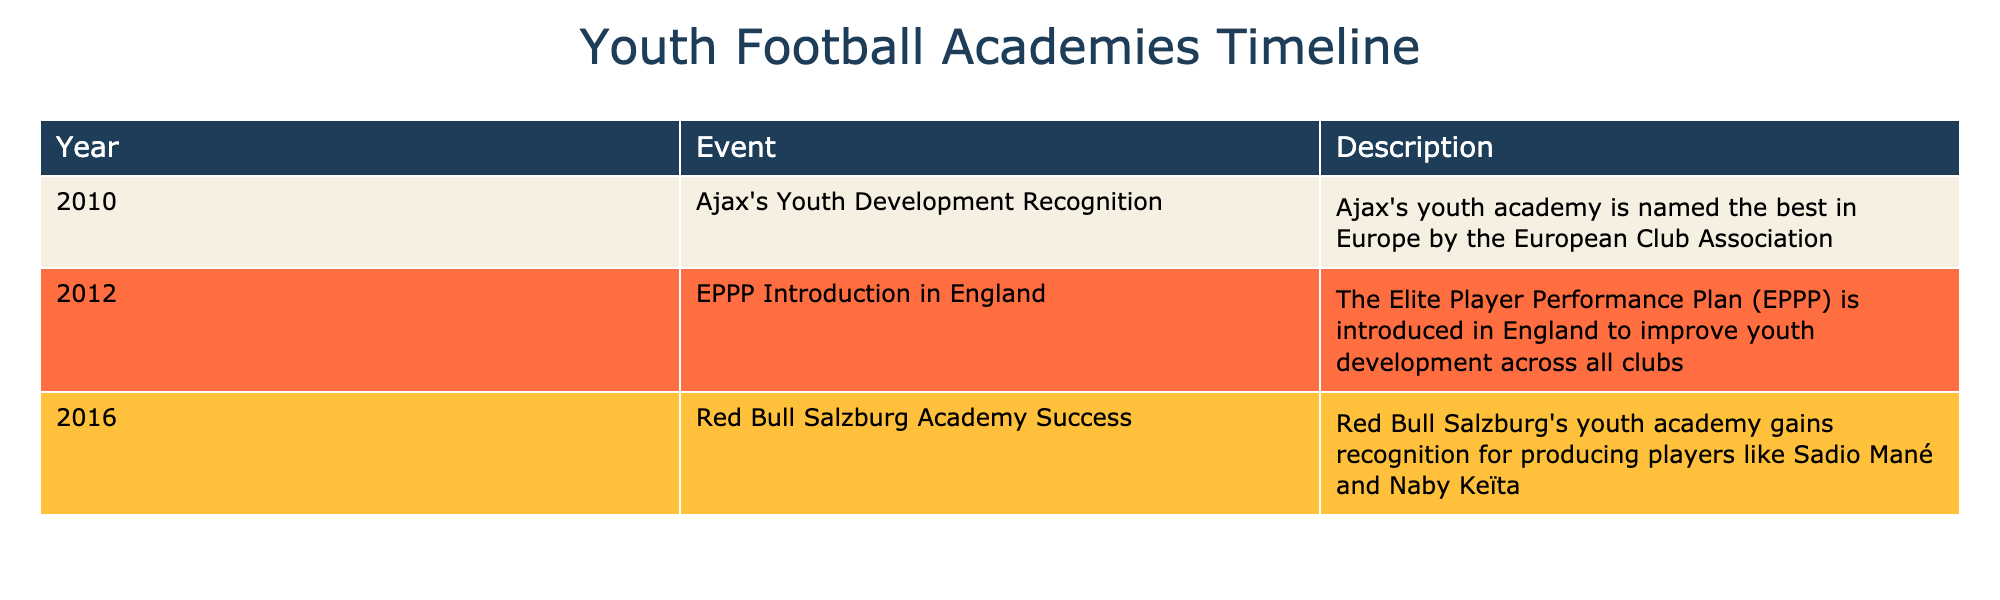What year did Ajax's youth academy receive recognition as the best in Europe? The table indicates that Ajax's youth academy was recognized as the best in Europe in the year 2010.
Answer: 2010 What significant event took place in England in 2012 regarding youth football academies? The table states that in 2012, the Elite Player Performance Plan (EPPP) was introduced in England to enhance youth development across all clubs.
Answer: The introduction of the EPPP In which year were both Ajax and Red Bull Salzburg recognized for their youth development? Ajax was recognized in 2010, while Red Bull Salzburg was recognized in 2016, indicating that there is no overlap in their recognition years.
Answer: There is no common year Which academy gained recognition specifically for producing Sadio Mané and Naby Keïta? According to the table, Red Bull Salzburg Academy gained recognition for producing players like Sadio Mané and Naby Keïta.
Answer: Red Bull Salzburg Academy Is it true that the years listed in the table are all within the last two decades? The years 2010, 2012, and 2016 are all within the range from 2003 to 2023, confirming that they are indeed within the last two decades.
Answer: Yes What is the time span between the establishment of the Elite Player Performance Plan and the recognition of the Red Bull Salzburg Academy? The EPPP was introduced in 2012, and Red Bull Salzburg Academy gained recognition in 2016. The time span from 2012 to 2016 is four years.
Answer: Four years 